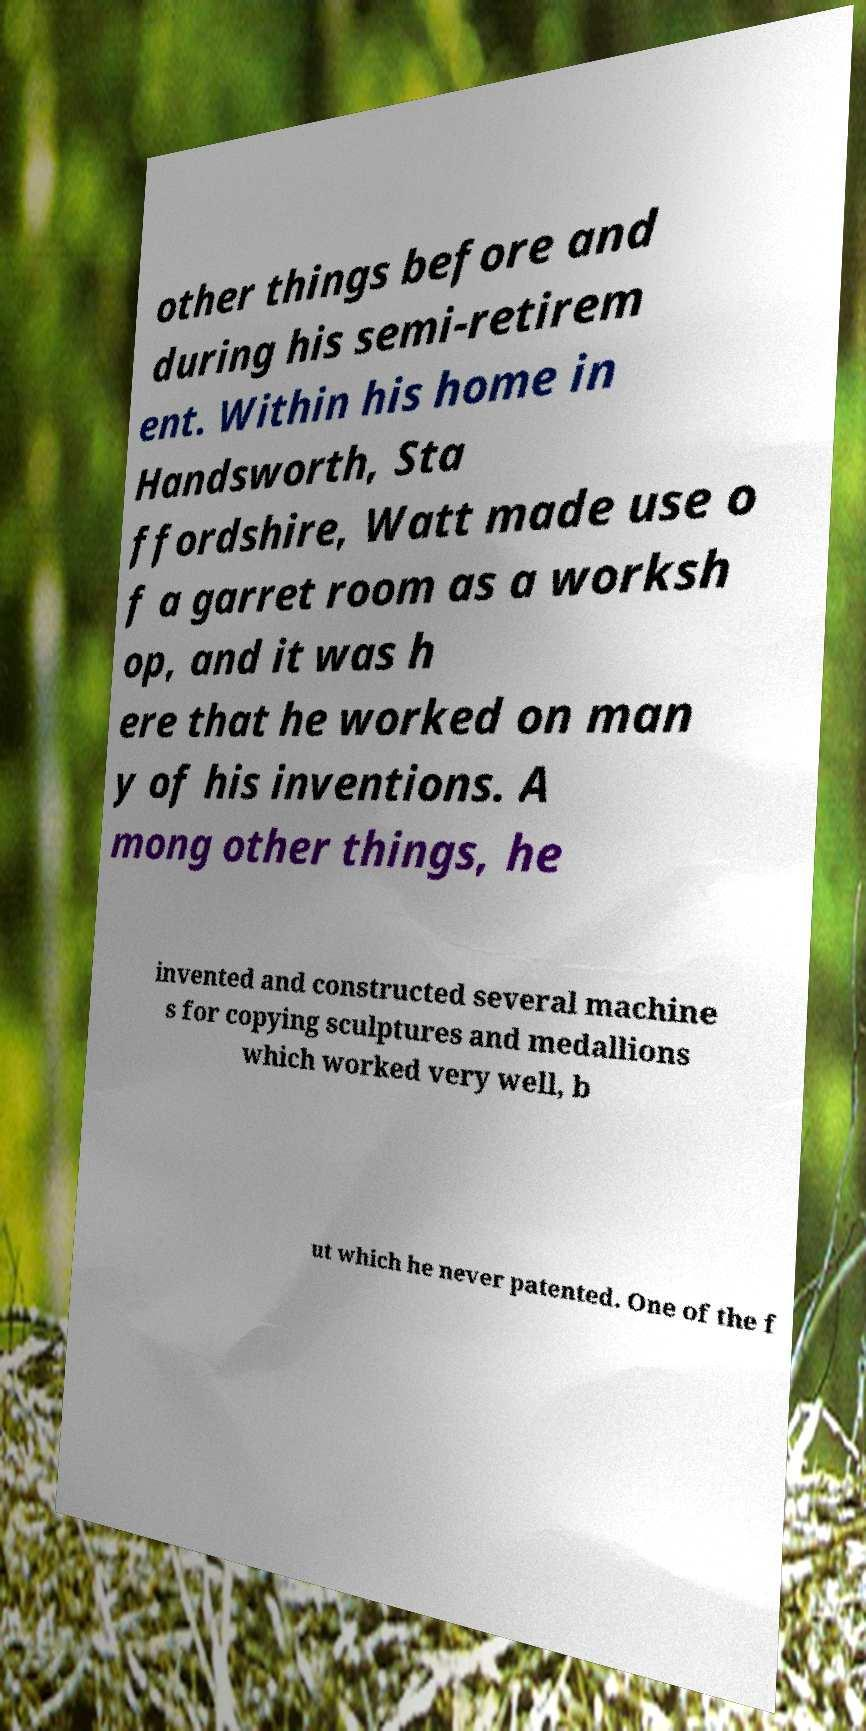Could you extract and type out the text from this image? other things before and during his semi-retirem ent. Within his home in Handsworth, Sta ffordshire, Watt made use o f a garret room as a worksh op, and it was h ere that he worked on man y of his inventions. A mong other things, he invented and constructed several machine s for copying sculptures and medallions which worked very well, b ut which he never patented. One of the f 